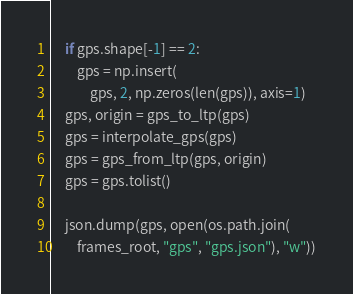<code> <loc_0><loc_0><loc_500><loc_500><_Python_>    if gps.shape[-1] == 2:
        gps = np.insert(
            gps, 2, np.zeros(len(gps)), axis=1)
    gps, origin = gps_to_ltp(gps)
    gps = interpolate_gps(gps)
    gps = gps_from_ltp(gps, origin)
    gps = gps.tolist()

    json.dump(gps, open(os.path.join(
        frames_root, "gps", "gps.json"), "w"))</code> 